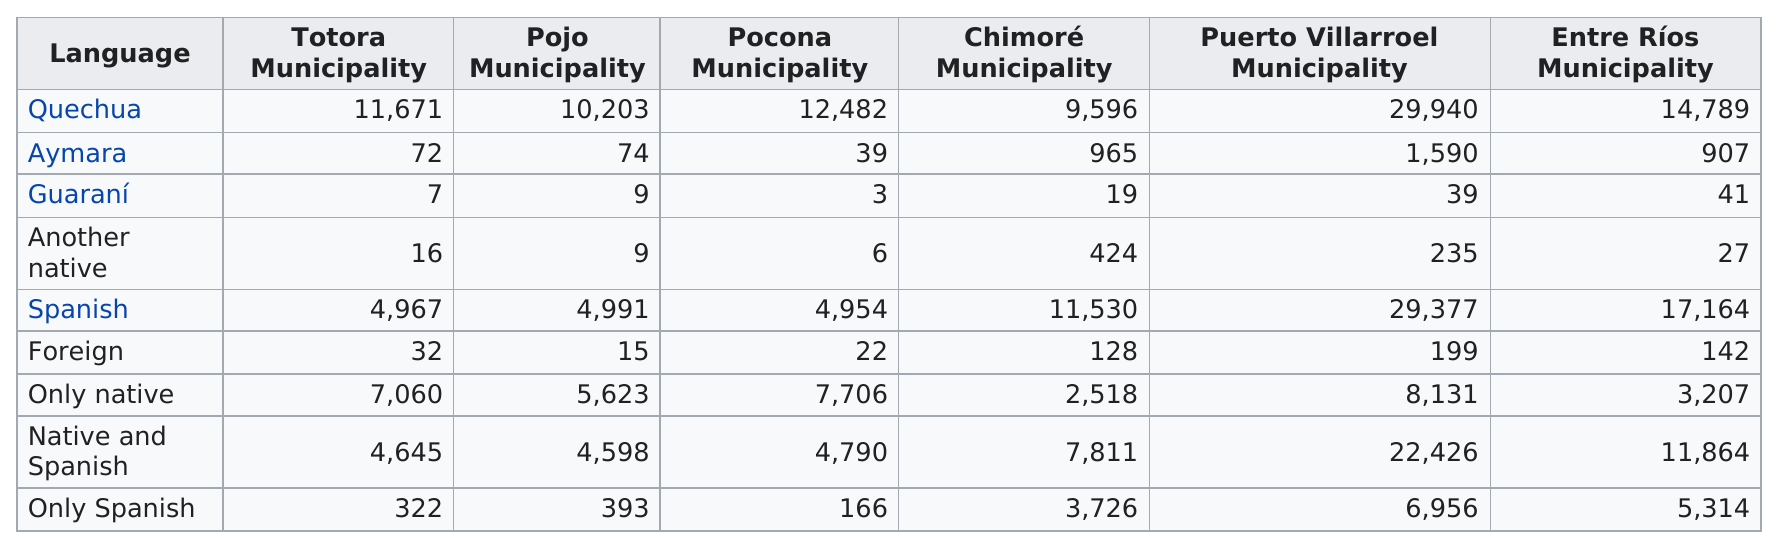Specify some key components in this picture. It is unknown which municipality has a larger Aymara population, Tortora or Pocona. Puerto Villarroel Municipality has the highest number of Quechua speakers among all municipalities. Puerto Villarroel Municipality is home to the largest number of Spanish speakers. The chart lists 4 distinct languages. In all municipalities, the number of languages spoken is less than 10. 